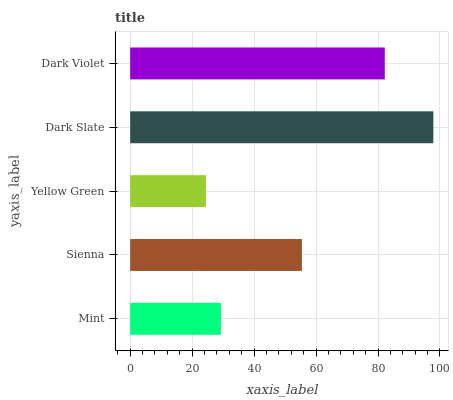Is Yellow Green the minimum?
Answer yes or no. Yes. Is Dark Slate the maximum?
Answer yes or no. Yes. Is Sienna the minimum?
Answer yes or no. No. Is Sienna the maximum?
Answer yes or no. No. Is Sienna greater than Mint?
Answer yes or no. Yes. Is Mint less than Sienna?
Answer yes or no. Yes. Is Mint greater than Sienna?
Answer yes or no. No. Is Sienna less than Mint?
Answer yes or no. No. Is Sienna the high median?
Answer yes or no. Yes. Is Sienna the low median?
Answer yes or no. Yes. Is Mint the high median?
Answer yes or no. No. Is Mint the low median?
Answer yes or no. No. 